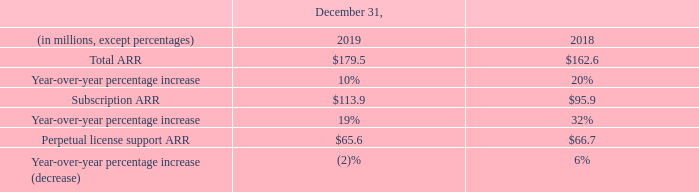Annual Recurring Revenue
Beginning with the fourth quarter of 2018, we began monitoring a new operating metric, total annual recurring revenue (“Total ARR”), which is defined as the annualized value of all recurring revenue contracts active at the end of a reporting period. Total ARR includes the annualized value of subscriptions (“Subscription ARR”) and the annualized value of software support contracts related to perpetual licenses (“Perpetual license support ARR”) active at the end of a reporting period and does not include revenue reported as perpetual license or professional services in our consolidated statement of operations. We are monitoring these metrics because they align with how our customers are increasingly purchasing our solutions and how we are managing our business. These ARR measures should be viewed independently of revenue, unearned revenue, and customer arrangements with termination rights as ARR is an operating metric and is not intended to be combined with or replace those items. ARR is not an indicator of future revenue and can be impacted by contract start and end dates and renewal rates.
ARR metrics as of December 31, 2019 and 2018 were as follows (unaudited):
When did the company start monitoring total annual recurring revenue?  Beginning with the fourth quarter of 2018. What were the values of subscription ARRs for the years 2019 and 2018 respectively?
Answer scale should be: million. $113.9, $95.9. What were the values of perpetual license support ARRs for the years 2019 and 2018 respectively?
Answer scale should be: million. $65.6, $66.7. What was the average year-over-year percentage increase of total ARRs  from 2018 to 2019?
Answer scale should be: percent. (10%+20%)/2
Answer: 15. How many years did total ARR exceed $162 million? 2019##2018
Answer: 2. What was the percentage change in the perpetual license support ARR from 2018 to 2019?
Answer scale should be: percent. (65.6-66.7)/66.7
Answer: -1.65. 